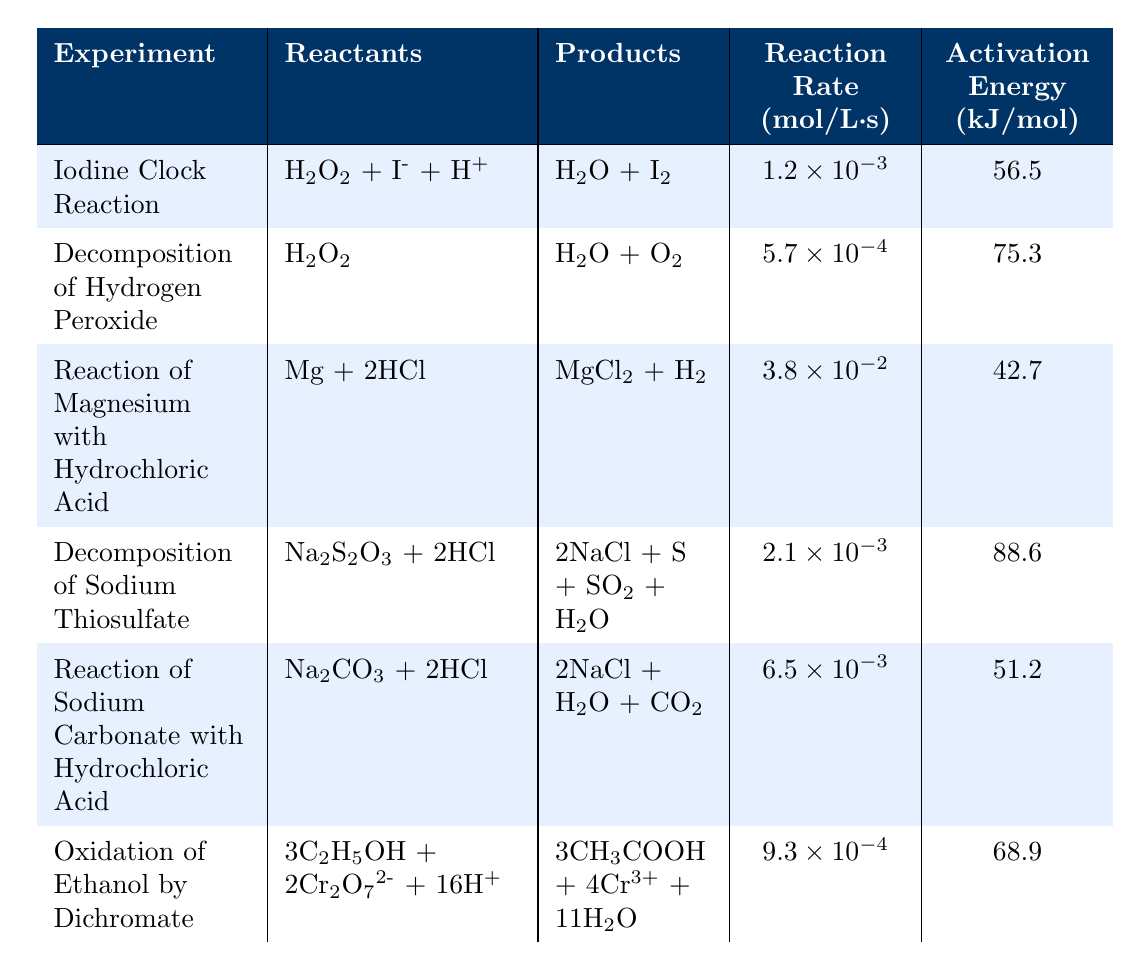What is the reaction rate for the Iodine Clock Reaction? The table lists the reaction rate for each experiment. For the Iodine Clock Reaction, it shows "1.2 × 10⁻³" mol/L·s.
Answer: 1.2 × 10⁻³ Which experiment has the highest activation energy? The activation energies for each experiment can be compared. The highest value listed in the table is "88.6" kJ/mol for the Decomposition of Sodium Thiosulfate.
Answer: 88.6 What are the products of the Reaction of Magnesium with Hydrochloric Acid? By looking at the corresponding row for this experiment in the table, it is listed that the products are "MgCl₂ + H₂."
Answer: MgCl₂ + H₂ Is the reaction rate for the Oxidation of Ethanol by Dichromate greater than that of the Decomposition of Hydrogen Peroxide? The reaction rate of the Oxidation of Ethanol is "9.3 × 10⁻⁴," and for Decomposition of Hydrogen Peroxide, it is "5.7 × 10⁻⁴." Comparing both values shows that "9.3 × 10⁻⁴" is greater than "5.7 × 10⁻⁴," thus the statement is true.
Answer: Yes What is the average activation energy of the reactions listed in the table? First, sum the activation energies: 56.5 + 75.3 + 42.7 + 88.6 + 51.2 + 68.9 = 383.2 kJ/mol. There are 6 experiments, so the average is 383.2 / 6 ≈ 63.87 kJ/mol.
Answer: 63.87 How many experiments have a reaction rate higher than 1 × 10⁻³ mol/L·s? By reviewing the reaction rates in the table, the Iodine Clock Reaction and the Reaction of Magnesium with Hydrochloric Acid rates are both greater than "1 × 10⁻³." Therefore, there are 2 such experiments.
Answer: 2 Which experiment involves sodium as a reactant? The table shows the Decomposition of Sodium Thiosulfate and the Reaction of Sodium Carbonate with Hydrochloric Acid both containing sodium in their reactants.
Answer: 2 Is the Reaction of Sodium Carbonate with Hydrochloric Acid more exothermic than the Decomposition of Hydrogen Peroxide based on their activation energies? Decomposition of Hydrogen Peroxide has an activation energy of "75.3" kJ/mol while the Reaction of Sodium Carbonate has "51.2" kJ/mol. Since the lower the activation energy generally indicates a more exothermic reaction, the Sodium Carbonate reaction is indeed more exothermic.
Answer: Yes What is the difference in reaction rates between the Reaction of Sodium Carbonate with Hydrochloric Acid and the Iodine Clock Reaction? The reaction rate for the Iodine Clock Reaction is "1.2 × 10⁻³" mol/L·s and for Sodium Carbonate, it is "6.5 × 10⁻³" mol/L·s. Calculating the difference, 6.5 × 10⁻³ - 1.2 × 10⁻³ = 5.3 × 10⁻³ mol/L·s.
Answer: 5.3 × 10⁻³ 